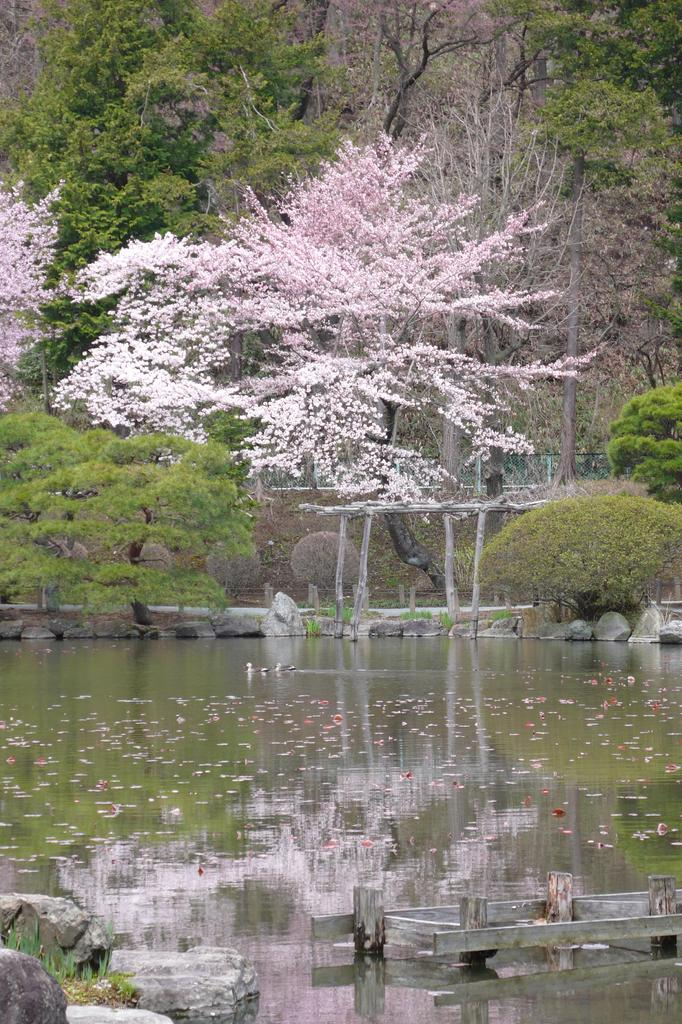What is the primary element present in the image? There is water in the image. What can be seen near the water? There are many rocks near the water. What type of object made of wood is in the image? There is a wooden object in the image. What type of vegetation is present in the image? There are trees in the image. What colors are the trees displaying? The trees have green, white, and light pink colors. What type of hat is being worn by the coast in the image? There is no coast or hat present in the image. What type of locket can be seen hanging from the tree in the image? There is no locket present in the image; only trees, water, rocks, and a wooden object are visible. 